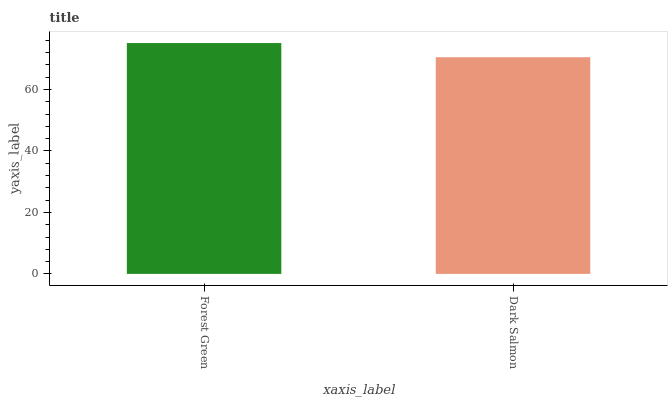Is Dark Salmon the maximum?
Answer yes or no. No. Is Forest Green greater than Dark Salmon?
Answer yes or no. Yes. Is Dark Salmon less than Forest Green?
Answer yes or no. Yes. Is Dark Salmon greater than Forest Green?
Answer yes or no. No. Is Forest Green less than Dark Salmon?
Answer yes or no. No. Is Forest Green the high median?
Answer yes or no. Yes. Is Dark Salmon the low median?
Answer yes or no. Yes. Is Dark Salmon the high median?
Answer yes or no. No. Is Forest Green the low median?
Answer yes or no. No. 